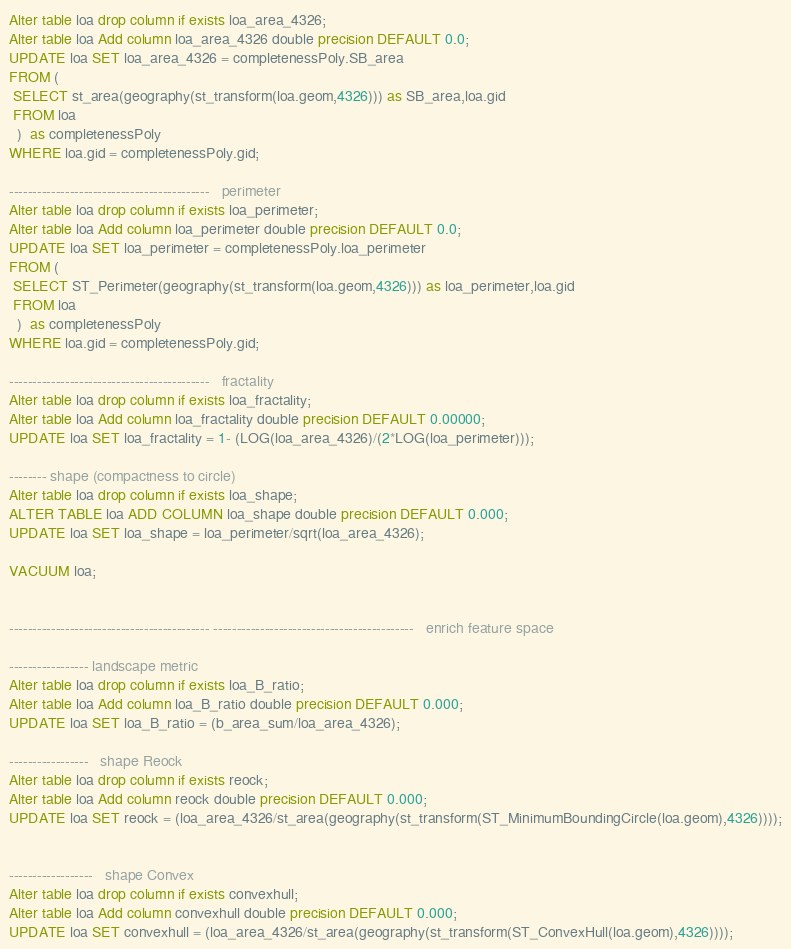<code> <loc_0><loc_0><loc_500><loc_500><_SQL_>Alter table loa drop column if exists loa_area_4326;
Alter table loa Add column loa_area_4326 double precision DEFAULT 0.0;
UPDATE loa SET loa_area_4326 = completenessPoly.SB_area 
FROM (
 SELECT st_area(geography(st_transform(loa.geom,4326))) as SB_area,loa.gid
 FROM loa
  )  as completenessPoly
WHERE loa.gid = completenessPoly.gid;

-------------------------------------------   perimeter
Alter table loa drop column if exists loa_perimeter;
Alter table loa Add column loa_perimeter double precision DEFAULT 0.0;
UPDATE loa SET loa_perimeter = completenessPoly.loa_perimeter 
FROM (
 SELECT ST_Perimeter(geography(st_transform(loa.geom,4326))) as loa_perimeter,loa.gid
 FROM loa
  )  as completenessPoly
WHERE loa.gid = completenessPoly.gid;

-------------------------------------------   fractality
Alter table loa drop column if exists loa_fractality;
Alter table loa Add column loa_fractality double precision DEFAULT 0.00000;
UPDATE loa SET loa_fractality = 1- (LOG(loa_area_4326)/(2*LOG(loa_perimeter)));

-------- shape (compactness to circle)
Alter table loa drop column if exists loa_shape;
ALTER TABLE loa ADD COLUMN loa_shape double precision DEFAULT 0.000;
UPDATE loa SET loa_shape = loa_perimeter/sqrt(loa_area_4326);

VACUUM loa;


------------------------------------------- -------------------------------------------   enrich feature space

----------------- landscape metric
Alter table loa drop column if exists loa_B_ratio;
Alter table loa Add column loa_B_ratio double precision DEFAULT 0.000;
UPDATE loa SET loa_B_ratio = (b_area_sum/loa_area_4326);

-----------------   shape Reock 
Alter table loa drop column if exists reock;
Alter table loa Add column reock double precision DEFAULT 0.000;
UPDATE loa SET reock = (loa_area_4326/st_area(geography(st_transform(ST_MinimumBoundingCircle(loa.geom),4326))));


------------------   shape Convex 
Alter table loa drop column if exists convexhull;
Alter table loa Add column convexhull double precision DEFAULT 0.000;
UPDATE loa SET convexhull = (loa_area_4326/st_area(geography(st_transform(ST_ConvexHull(loa.geom),4326))));</code> 